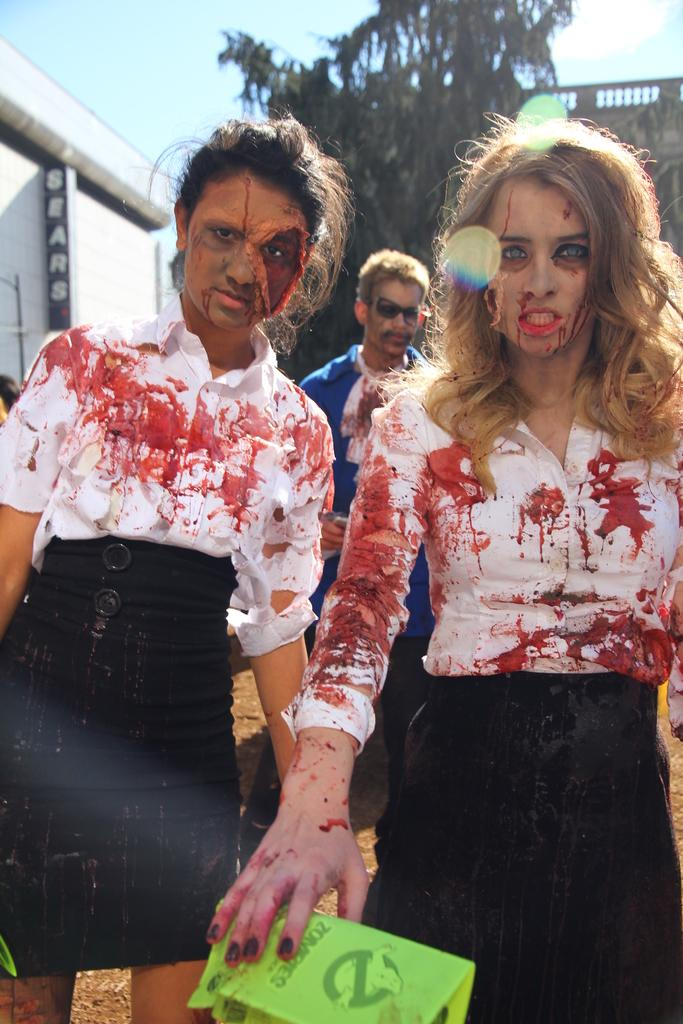How many people are in the group in the image? There is a group of people in the image, but the exact number cannot be determined from the provided facts. What are some people in the group wearing? Some people in the group are wearing costumes. What can be seen in the background of the image? There are trees and buildings in the background of the image. What type of cheese is being used to play chess in the image? There is no cheese or chess game present in the image. 